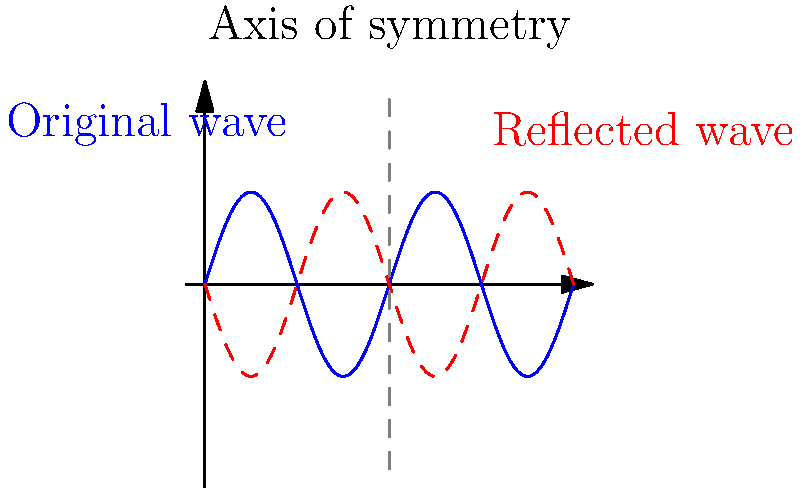In the diagram above, a sound wave pattern (blue) and its reflection (red) are shown. If the axis of symmetry is at $x=1$, what would be the equation of the reflected wave if the original wave is given by $y=0.5\sin(2\pi x)$? To find the equation of the reflected wave, we need to follow these steps:

1. Identify the original wave equation: $y=0.5\sin(2\pi x)$

2. Understand the reflection: The wave is reflected over the vertical line $x=1$

3. To reflect a function over a vertical line $x=a$, we replace $x$ with $(2a-x)$ in the original equation. In this case, $a=1$

4. Substitute $(2-x)$ for $x$ in the original equation:
   $y = 0.5\sin(2\pi(2-x))$

5. Simplify the argument of the sine function:
   $y = 0.5\sin(4\pi-2\pi x)$

6. Use the trigonometric identity $\sin(A-B) = \sin A \cos B - \cos A \sin B$:
   $y = 0.5[\sin(4\pi)\cos(2\pi x) - \cos(4\pi)\sin(2\pi x)]$

7. Simplify, knowing that $\sin(4\pi)=0$ and $\cos(4\pi)=1$:
   $y = 0.5[-\sin(2\pi x)] = -0.5\sin(2\pi x)$

Therefore, the equation of the reflected wave is $y=-0.5\sin(2\pi x)$.
Answer: $y=-0.5\sin(2\pi x)$ 